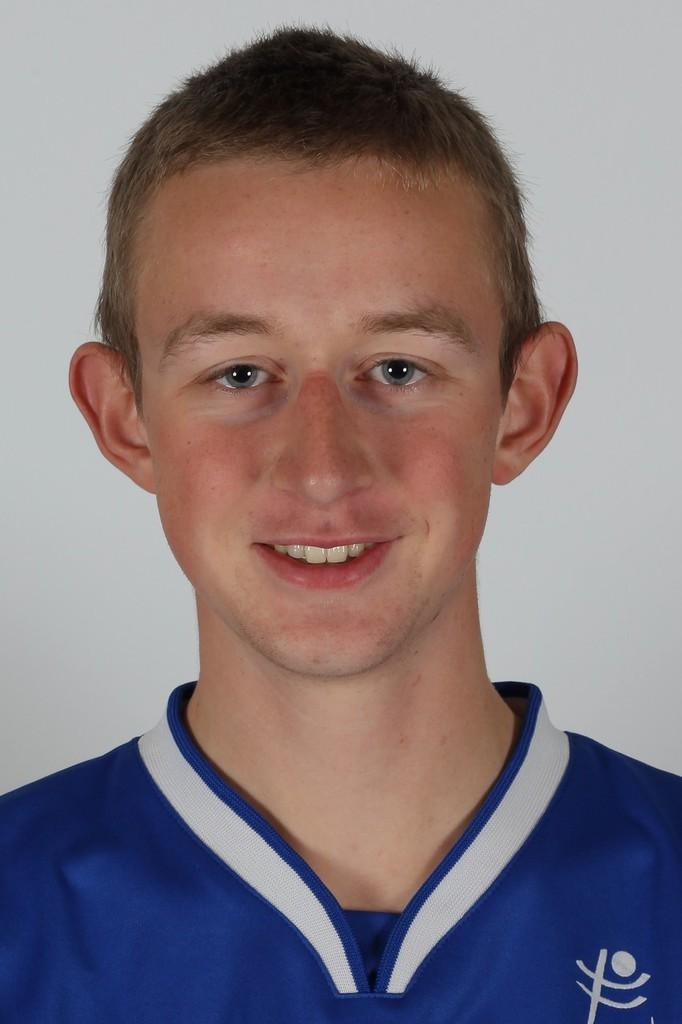What is the main subject in the foreground of the image? There is a boy in the foreground of the image. What is the boy doing in the image? The boy is looking at someone. What color is the dress the boy is wearing? The boy is wearing a blue color dress. What is the color of the background in the image? The background of the image is white. Can you see any fairies flying around the boy in the image? There are no fairies present in the image. What type of bed is the boy lying on in the image? The image does not show the boy lying on a bed; he is standing and looking at someone. 